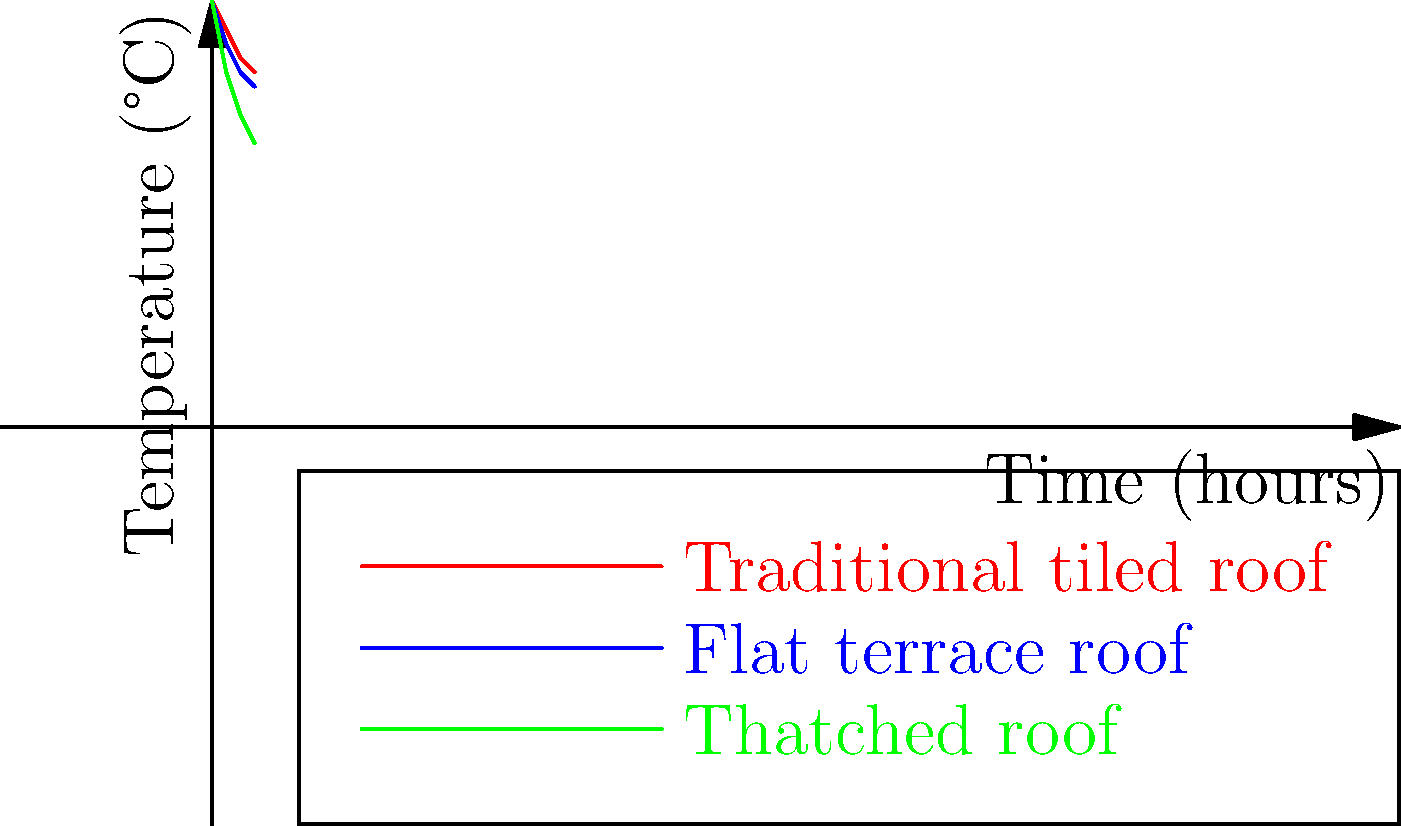The graph shows the thermal insulation properties of three traditional roof designs found in historical Tamil Nadu architecture. Which roof type demonstrates the best thermal insulation performance over a 3-hour period, and what is the approximate temperature difference (in °C) between the best and worst performing roofs at the 3-hour mark? To answer this question, we need to analyze the graph and follow these steps:

1. Identify the roof types:
   - Red line: Traditional tiled roof
   - Blue line: Flat terrace roof
   - Green line: Thatched roof

2. Determine the best thermal insulation performance:
   The roof type with the lowest temperature at the 3-hour mark has the best thermal insulation.
   At 3 hours:
   - Traditional tiled roof: ~25°C
   - Flat terrace roof: ~24°C
   - Thatched roof: ~20°C

   The thatched roof (green line) shows the lowest temperature, indicating the best thermal insulation.

3. Calculate the temperature difference between the best and worst performing roofs:
   - Best performing (Thatched roof): ~20°C
   - Worst performing (Traditional tiled roof): ~25°C
   
   Temperature difference = 25°C - 20°C = 5°C

Therefore, the thatched roof demonstrates the best thermal insulation performance, and the approximate temperature difference between the best (thatched) and worst (traditional tiled) performing roofs at the 3-hour mark is 5°C.
Answer: Thatched roof; 5°C 